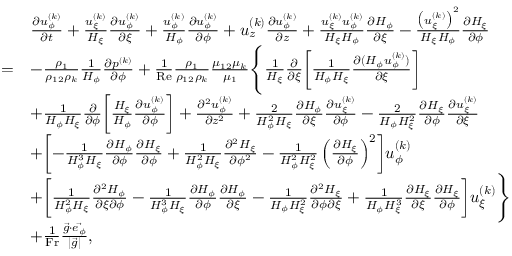<formula> <loc_0><loc_0><loc_500><loc_500>\begin{array} { r l } & { \begin{array} { r l } & { \frac { \partial u _ { \phi } ^ { ( k ) } } { \partial t } + \frac { u _ { \xi } ^ { ( k ) } } { H _ { \xi } } \frac { \partial u _ { \phi } ^ { ( k ) } } { \partial \xi } + \frac { u _ { \phi } ^ { ( k ) } } { H _ { \phi } } \frac { \partial u _ { \phi } ^ { ( k ) } } { \partial \phi } + u _ { z } ^ { ( k ) } \frac { \partial u _ { \phi } ^ { ( k ) } } { \partial z } + \frac { u _ { \xi } ^ { ( k ) } u _ { \phi } ^ { ( k ) } } { H _ { \xi } H _ { \phi } } \frac { \partial H _ { \phi } } { \partial \xi } - \frac { \left ( u _ { \xi } ^ { ( k ) } \right ) ^ { 2 } } { H _ { \xi } H _ { \phi } } \frac { \partial H _ { \xi } } { \partial \phi } } \\ { = } & { - \frac { \rho _ { 1 } } { \rho _ { 1 2 } \rho _ { k } } \frac { 1 } { H _ { \phi } } \frac { \partial p ^ { ( k ) } } { \partial \phi } + \frac { 1 } { R e } \frac { \rho _ { 1 } } { \rho _ { 1 2 } \rho _ { k } } \frac { \mu _ { 1 2 } \mu _ { k } } { \mu _ { 1 } } \left \{ \frac { 1 } { H _ { \xi } } \frac { \partial } { \partial \xi } \left [ \frac { 1 } { H _ { \phi } H _ { \xi } } \frac { \partial ( H _ { \phi } u _ { \phi } ^ { ( k ) } ) } { \partial \xi } \right ] } \\ & { + \frac { 1 } { H _ { \phi } H _ { \xi } } \frac { \partial } { \partial \phi } \left [ \frac { H _ { \xi } } { H _ { \phi } } \frac { \partial u _ { \phi } ^ { ( k ) } } { \partial \phi } \right ] + \frac { \partial ^ { 2 } u _ { \phi } ^ { ( k ) } } { \partial z ^ { 2 } } + \frac { 2 } { H _ { \phi } ^ { 2 } H _ { \xi } } \frac { \partial H _ { \phi } } { \partial \xi } \frac { \partial u _ { \xi } ^ { ( k ) } } { \partial \phi } - \frac { 2 } { H _ { \phi } H _ { \xi } ^ { 2 } } \frac { \partial H _ { \xi } } { \partial \phi } \frac { \partial u _ { \xi } ^ { ( k ) } } { \partial \xi } } \\ & { + \left [ - \frac { 1 } { H _ { \phi } ^ { 3 } H _ { \xi } } \frac { \partial H _ { \phi } } { \partial \phi } \frac { \partial H _ { \xi } } { \partial \phi } + \frac { 1 } { H _ { \phi } ^ { 2 } H _ { \xi } } \frac { \partial ^ { 2 } H _ { \xi } } { \partial \phi ^ { 2 } } - \frac { 1 } { H _ { \phi } ^ { 2 } H _ { \xi } ^ { 2 } } \left ( \frac { \partial H _ { \xi } } { \partial \phi } \right ) ^ { 2 } \right ] u _ { \phi } ^ { ( k ) } } \\ & { + \left [ \frac { 1 } { H _ { \phi } ^ { 2 } H _ { \xi } } \frac { \partial ^ { 2 } H _ { \phi } } { \partial \xi \partial \phi } - \frac { 1 } { H _ { \phi } ^ { 3 } H _ { \xi } } \frac { \partial H _ { \phi } } { \partial \phi } \frac { \partial H _ { \phi } } { \partial \xi } - \frac { 1 } { H _ { \phi } H _ { \xi } ^ { 2 } } \frac { \partial ^ { 2 } H _ { \xi } } { \partial \phi \partial \xi } + \frac { 1 } { H _ { \phi } H _ { \xi } ^ { 3 } } \frac { \partial H _ { \xi } } { \partial \xi } \frac { \partial H _ { \xi } } { \partial \phi } \right ] u _ { \xi } ^ { ( k ) } \right \} } \\ & { + \frac { 1 } { F r } \frac { \vec { g } \cdot \vec { e _ { \phi } } } { | \vec { g } | } , } \end{array} } \end{array}</formula> 